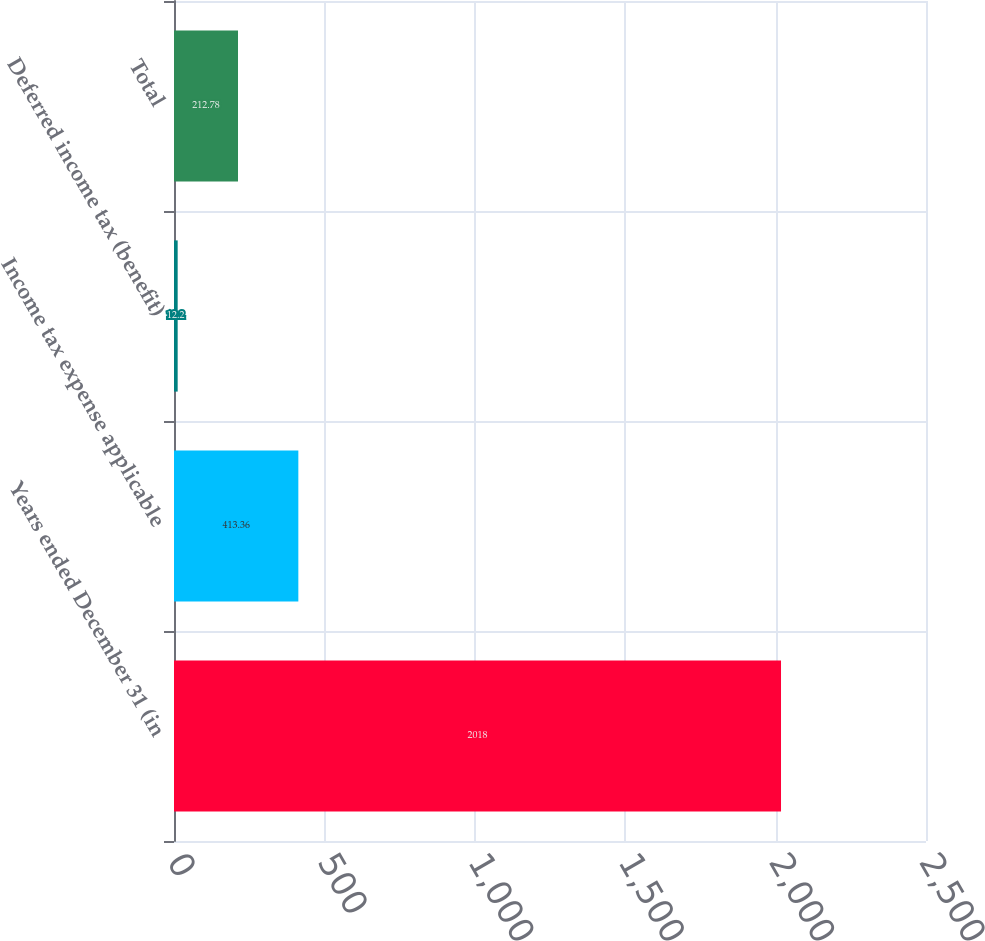<chart> <loc_0><loc_0><loc_500><loc_500><bar_chart><fcel>Years ended December 31 (in<fcel>Income tax expense applicable<fcel>Deferred income tax (benefit)<fcel>Total<nl><fcel>2018<fcel>413.36<fcel>12.2<fcel>212.78<nl></chart> 